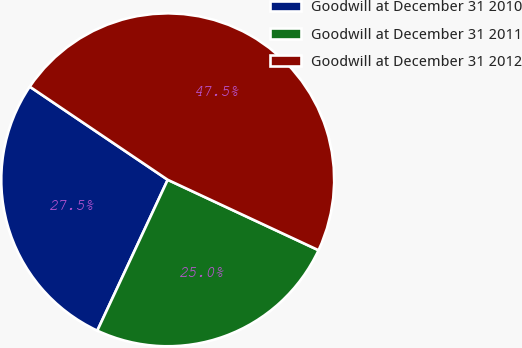Convert chart to OTSL. <chart><loc_0><loc_0><loc_500><loc_500><pie_chart><fcel>Goodwill at December 31 2010<fcel>Goodwill at December 31 2011<fcel>Goodwill at December 31 2012<nl><fcel>27.5%<fcel>25.0%<fcel>47.5%<nl></chart> 